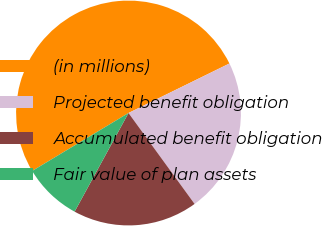Convert chart. <chart><loc_0><loc_0><loc_500><loc_500><pie_chart><fcel>(in millions)<fcel>Projected benefit obligation<fcel>Accumulated benefit obligation<fcel>Fair value of plan assets<nl><fcel>51.36%<fcel>22.26%<fcel>17.96%<fcel>8.42%<nl></chart> 